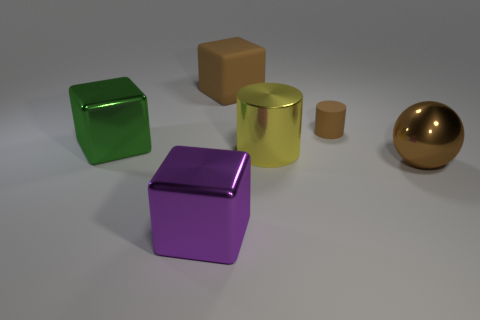Is there anything else that has the same size as the rubber cylinder?
Give a very brief answer. No. Is the color of the small object behind the large brown shiny thing the same as the large ball?
Make the answer very short. Yes. What is the shape of the big metal thing that is both in front of the large yellow metal cylinder and left of the small cylinder?
Your answer should be very brief. Cube. What is the color of the shiny block that is in front of the big green thing?
Your response must be concise. Purple. Is there any other thing that is the same color as the large metal cylinder?
Your response must be concise. No. Is the size of the purple shiny thing the same as the ball?
Make the answer very short. Yes. There is a brown object that is both to the right of the large yellow metal cylinder and behind the big green cube; what is its size?
Your answer should be compact. Small. How many purple objects have the same material as the sphere?
Ensure brevity in your answer.  1. What shape is the small object that is the same color as the large metallic ball?
Give a very brief answer. Cylinder. What color is the big shiny sphere?
Keep it short and to the point. Brown. 